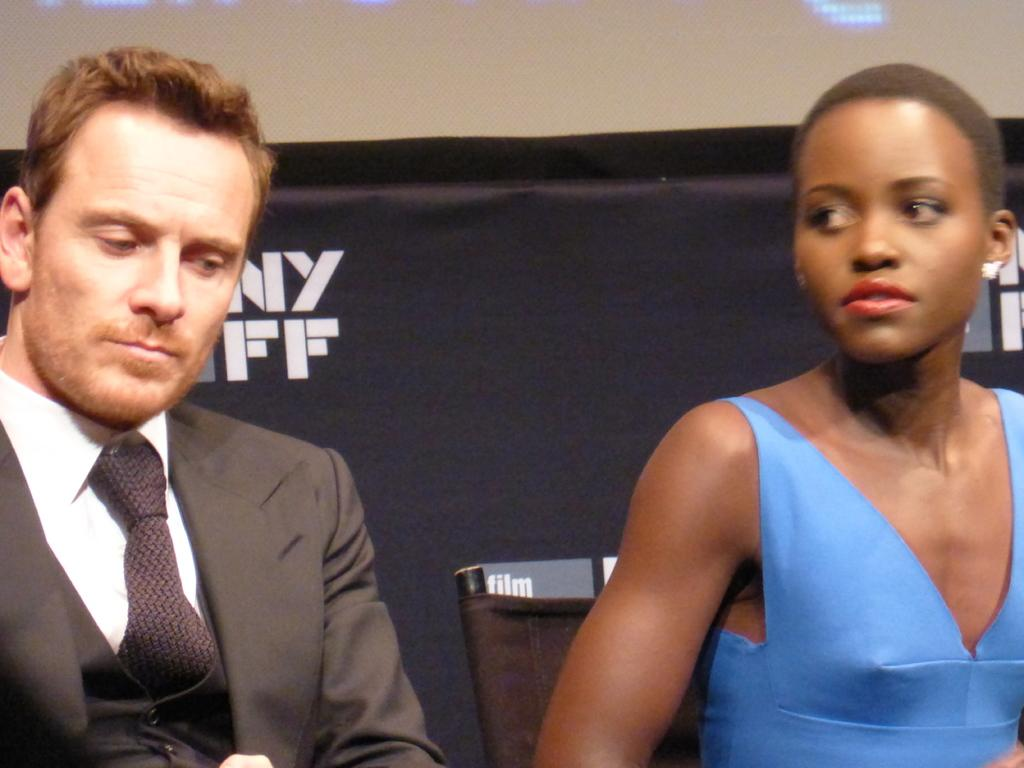How many people are present in the image? There is a man and a woman in the image. What can be seen in the background of the image? There is a poster and lights in the background of the image. What type of son can be seen playing with a giraffe in the image? There is no son or giraffe present in the image. What kind of voyage are the people in the image embarking on? There is no indication of a voyage in the image; it simply shows a man and a woman with a poster and lights in the background. 